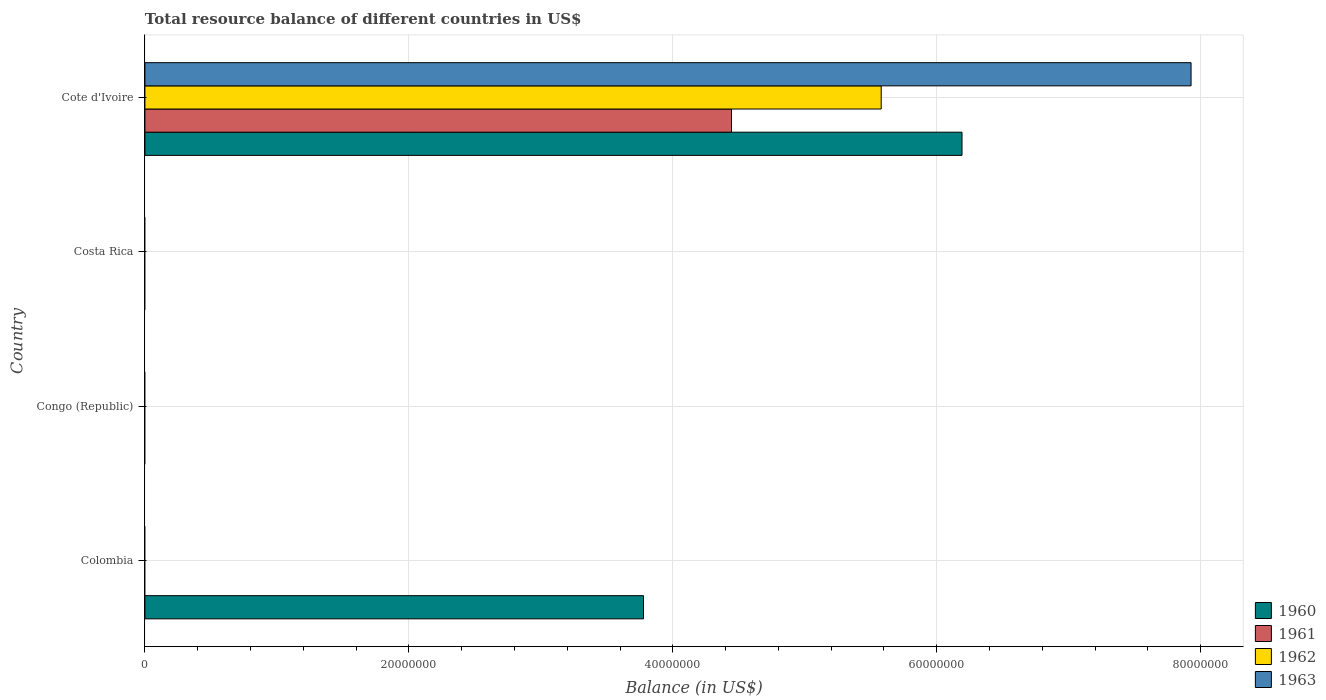How many different coloured bars are there?
Offer a terse response. 4. Are the number of bars on each tick of the Y-axis equal?
Provide a succinct answer. No. How many bars are there on the 2nd tick from the top?
Make the answer very short. 0. How many bars are there on the 1st tick from the bottom?
Offer a very short reply. 1. Across all countries, what is the maximum total resource balance in 1963?
Make the answer very short. 7.93e+07. Across all countries, what is the minimum total resource balance in 1960?
Keep it short and to the point. 0. In which country was the total resource balance in 1961 maximum?
Give a very brief answer. Cote d'Ivoire. What is the total total resource balance in 1961 in the graph?
Provide a succinct answer. 4.44e+07. What is the difference between the total resource balance in 1960 in Colombia and that in Cote d'Ivoire?
Offer a very short reply. -2.41e+07. What is the difference between the total resource balance in 1960 in Cote d'Ivoire and the total resource balance in 1963 in Costa Rica?
Your answer should be compact. 6.19e+07. What is the average total resource balance in 1960 per country?
Provide a succinct answer. 2.49e+07. What is the difference between the total resource balance in 1962 and total resource balance in 1961 in Cote d'Ivoire?
Offer a very short reply. 1.13e+07. What is the difference between the highest and the lowest total resource balance in 1963?
Ensure brevity in your answer.  7.93e+07. Is it the case that in every country, the sum of the total resource balance in 1961 and total resource balance in 1962 is greater than the sum of total resource balance in 1960 and total resource balance in 1963?
Provide a short and direct response. No. Is it the case that in every country, the sum of the total resource balance in 1963 and total resource balance in 1960 is greater than the total resource balance in 1962?
Give a very brief answer. No. How many bars are there?
Ensure brevity in your answer.  5. How many countries are there in the graph?
Your response must be concise. 4. Are the values on the major ticks of X-axis written in scientific E-notation?
Make the answer very short. No. What is the title of the graph?
Provide a short and direct response. Total resource balance of different countries in US$. Does "1986" appear as one of the legend labels in the graph?
Your response must be concise. No. What is the label or title of the X-axis?
Your answer should be very brief. Balance (in US$). What is the label or title of the Y-axis?
Your answer should be very brief. Country. What is the Balance (in US$) in 1960 in Colombia?
Your response must be concise. 3.78e+07. What is the Balance (in US$) in 1961 in Colombia?
Offer a very short reply. 0. What is the Balance (in US$) in 1960 in Congo (Republic)?
Provide a succinct answer. 0. What is the Balance (in US$) in 1963 in Congo (Republic)?
Offer a terse response. 0. What is the Balance (in US$) of 1960 in Costa Rica?
Provide a short and direct response. 0. What is the Balance (in US$) of 1961 in Costa Rica?
Your response must be concise. 0. What is the Balance (in US$) of 1963 in Costa Rica?
Make the answer very short. 0. What is the Balance (in US$) of 1960 in Cote d'Ivoire?
Your answer should be very brief. 6.19e+07. What is the Balance (in US$) of 1961 in Cote d'Ivoire?
Provide a short and direct response. 4.44e+07. What is the Balance (in US$) in 1962 in Cote d'Ivoire?
Provide a short and direct response. 5.58e+07. What is the Balance (in US$) of 1963 in Cote d'Ivoire?
Your response must be concise. 7.93e+07. Across all countries, what is the maximum Balance (in US$) of 1960?
Ensure brevity in your answer.  6.19e+07. Across all countries, what is the maximum Balance (in US$) of 1961?
Your answer should be compact. 4.44e+07. Across all countries, what is the maximum Balance (in US$) of 1962?
Give a very brief answer. 5.58e+07. Across all countries, what is the maximum Balance (in US$) of 1963?
Your answer should be very brief. 7.93e+07. Across all countries, what is the minimum Balance (in US$) in 1960?
Provide a short and direct response. 0. Across all countries, what is the minimum Balance (in US$) in 1962?
Ensure brevity in your answer.  0. What is the total Balance (in US$) in 1960 in the graph?
Your answer should be very brief. 9.97e+07. What is the total Balance (in US$) of 1961 in the graph?
Provide a short and direct response. 4.44e+07. What is the total Balance (in US$) in 1962 in the graph?
Your response must be concise. 5.58e+07. What is the total Balance (in US$) of 1963 in the graph?
Offer a terse response. 7.93e+07. What is the difference between the Balance (in US$) of 1960 in Colombia and that in Cote d'Ivoire?
Offer a terse response. -2.41e+07. What is the difference between the Balance (in US$) in 1960 in Colombia and the Balance (in US$) in 1961 in Cote d'Ivoire?
Ensure brevity in your answer.  -6.67e+06. What is the difference between the Balance (in US$) in 1960 in Colombia and the Balance (in US$) in 1962 in Cote d'Ivoire?
Your answer should be very brief. -1.80e+07. What is the difference between the Balance (in US$) in 1960 in Colombia and the Balance (in US$) in 1963 in Cote d'Ivoire?
Make the answer very short. -4.15e+07. What is the average Balance (in US$) in 1960 per country?
Give a very brief answer. 2.49e+07. What is the average Balance (in US$) of 1961 per country?
Provide a short and direct response. 1.11e+07. What is the average Balance (in US$) in 1962 per country?
Give a very brief answer. 1.39e+07. What is the average Balance (in US$) of 1963 per country?
Offer a terse response. 1.98e+07. What is the difference between the Balance (in US$) of 1960 and Balance (in US$) of 1961 in Cote d'Ivoire?
Offer a very short reply. 1.75e+07. What is the difference between the Balance (in US$) of 1960 and Balance (in US$) of 1962 in Cote d'Ivoire?
Offer a very short reply. 6.12e+06. What is the difference between the Balance (in US$) of 1960 and Balance (in US$) of 1963 in Cote d'Ivoire?
Make the answer very short. -1.74e+07. What is the difference between the Balance (in US$) of 1961 and Balance (in US$) of 1962 in Cote d'Ivoire?
Give a very brief answer. -1.13e+07. What is the difference between the Balance (in US$) of 1961 and Balance (in US$) of 1963 in Cote d'Ivoire?
Provide a succinct answer. -3.48e+07. What is the difference between the Balance (in US$) in 1962 and Balance (in US$) in 1963 in Cote d'Ivoire?
Your answer should be very brief. -2.35e+07. What is the ratio of the Balance (in US$) in 1960 in Colombia to that in Cote d'Ivoire?
Offer a very short reply. 0.61. What is the difference between the highest and the lowest Balance (in US$) in 1960?
Provide a succinct answer. 6.19e+07. What is the difference between the highest and the lowest Balance (in US$) in 1961?
Offer a terse response. 4.44e+07. What is the difference between the highest and the lowest Balance (in US$) in 1962?
Give a very brief answer. 5.58e+07. What is the difference between the highest and the lowest Balance (in US$) of 1963?
Ensure brevity in your answer.  7.93e+07. 